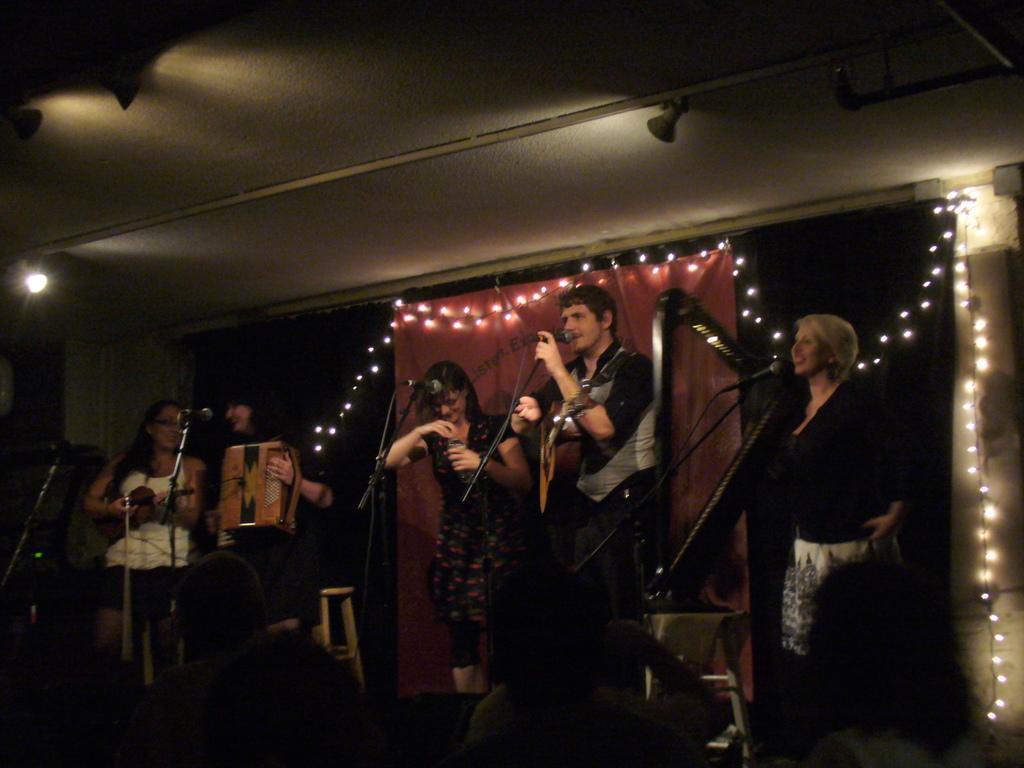In one or two sentences, can you explain what this image depicts? In the center of the image we can see people standing. On the left there are two ladies playing musical instruments. We can see mics placed on the stands. In the background there is a banner, lights and decors. At the bottom we can see crowd. 